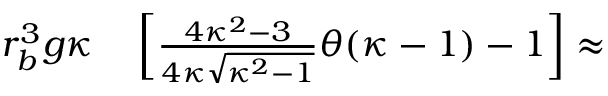<formula> <loc_0><loc_0><loc_500><loc_500>\begin{array} { r l } { r _ { b } ^ { 3 } g \kappa } & \left [ \frac { 4 \kappa ^ { 2 } - 3 } { 4 \kappa \sqrt { \kappa ^ { 2 } - 1 } } \theta ( \kappa - 1 ) - 1 \right ] \approx } \end{array}</formula> 